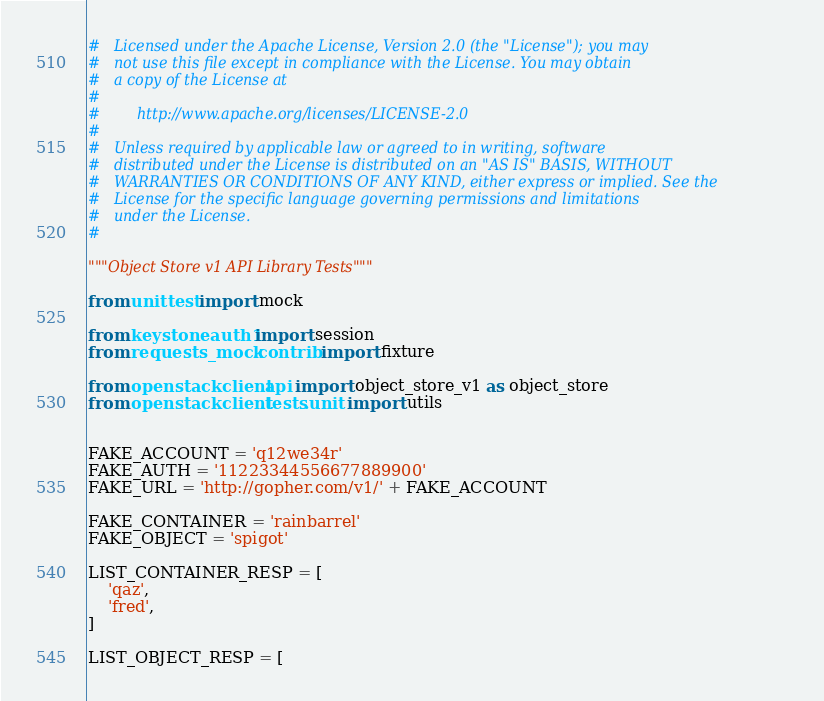<code> <loc_0><loc_0><loc_500><loc_500><_Python_>#   Licensed under the Apache License, Version 2.0 (the "License"); you may
#   not use this file except in compliance with the License. You may obtain
#   a copy of the License at
#
#        http://www.apache.org/licenses/LICENSE-2.0
#
#   Unless required by applicable law or agreed to in writing, software
#   distributed under the License is distributed on an "AS IS" BASIS, WITHOUT
#   WARRANTIES OR CONDITIONS OF ANY KIND, either express or implied. See the
#   License for the specific language governing permissions and limitations
#   under the License.
#

"""Object Store v1 API Library Tests"""

from unittest import mock

from keystoneauth1 import session
from requests_mock.contrib import fixture

from openstackclient.api import object_store_v1 as object_store
from openstackclient.tests.unit import utils


FAKE_ACCOUNT = 'q12we34r'
FAKE_AUTH = '11223344556677889900'
FAKE_URL = 'http://gopher.com/v1/' + FAKE_ACCOUNT

FAKE_CONTAINER = 'rainbarrel'
FAKE_OBJECT = 'spigot'

LIST_CONTAINER_RESP = [
    'qaz',
    'fred',
]

LIST_OBJECT_RESP = [</code> 